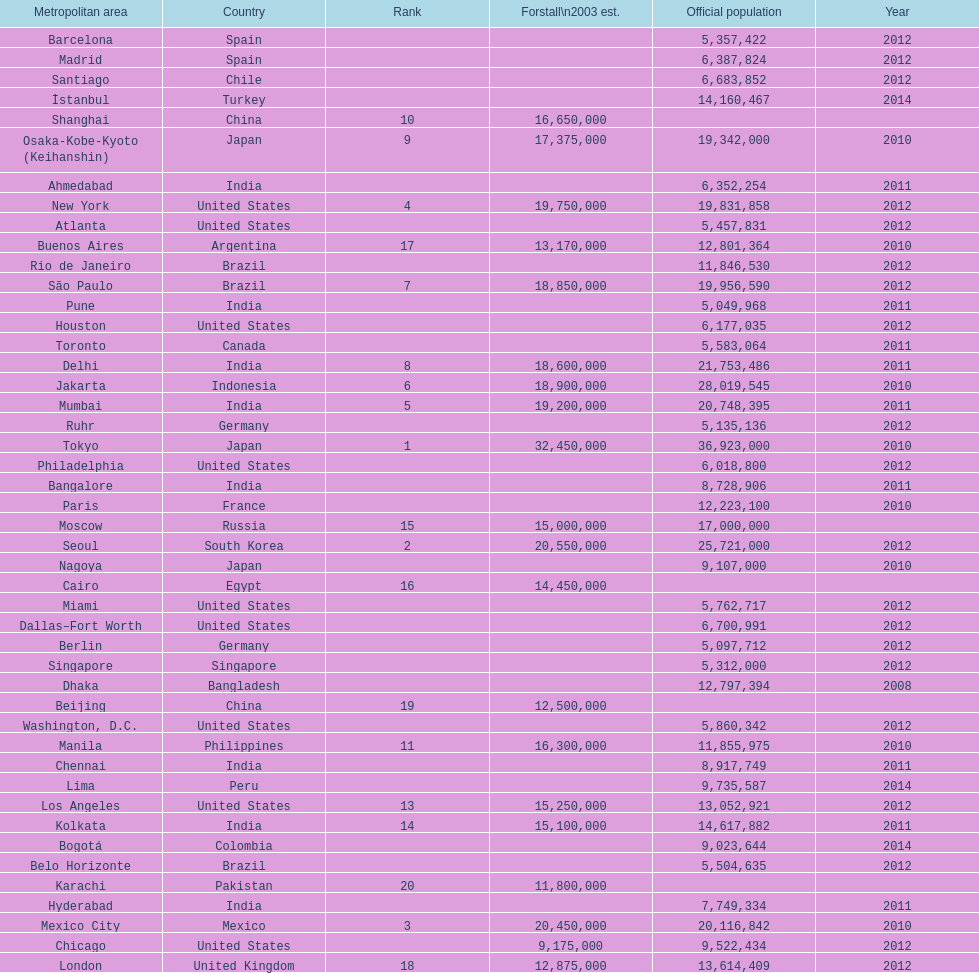Which territory is cited above chicago? Chennai. 